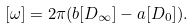Convert formula to latex. <formula><loc_0><loc_0><loc_500><loc_500>[ \omega ] = 2 \pi ( b [ D _ { \infty } ] - a [ D _ { 0 } ] ) .</formula> 